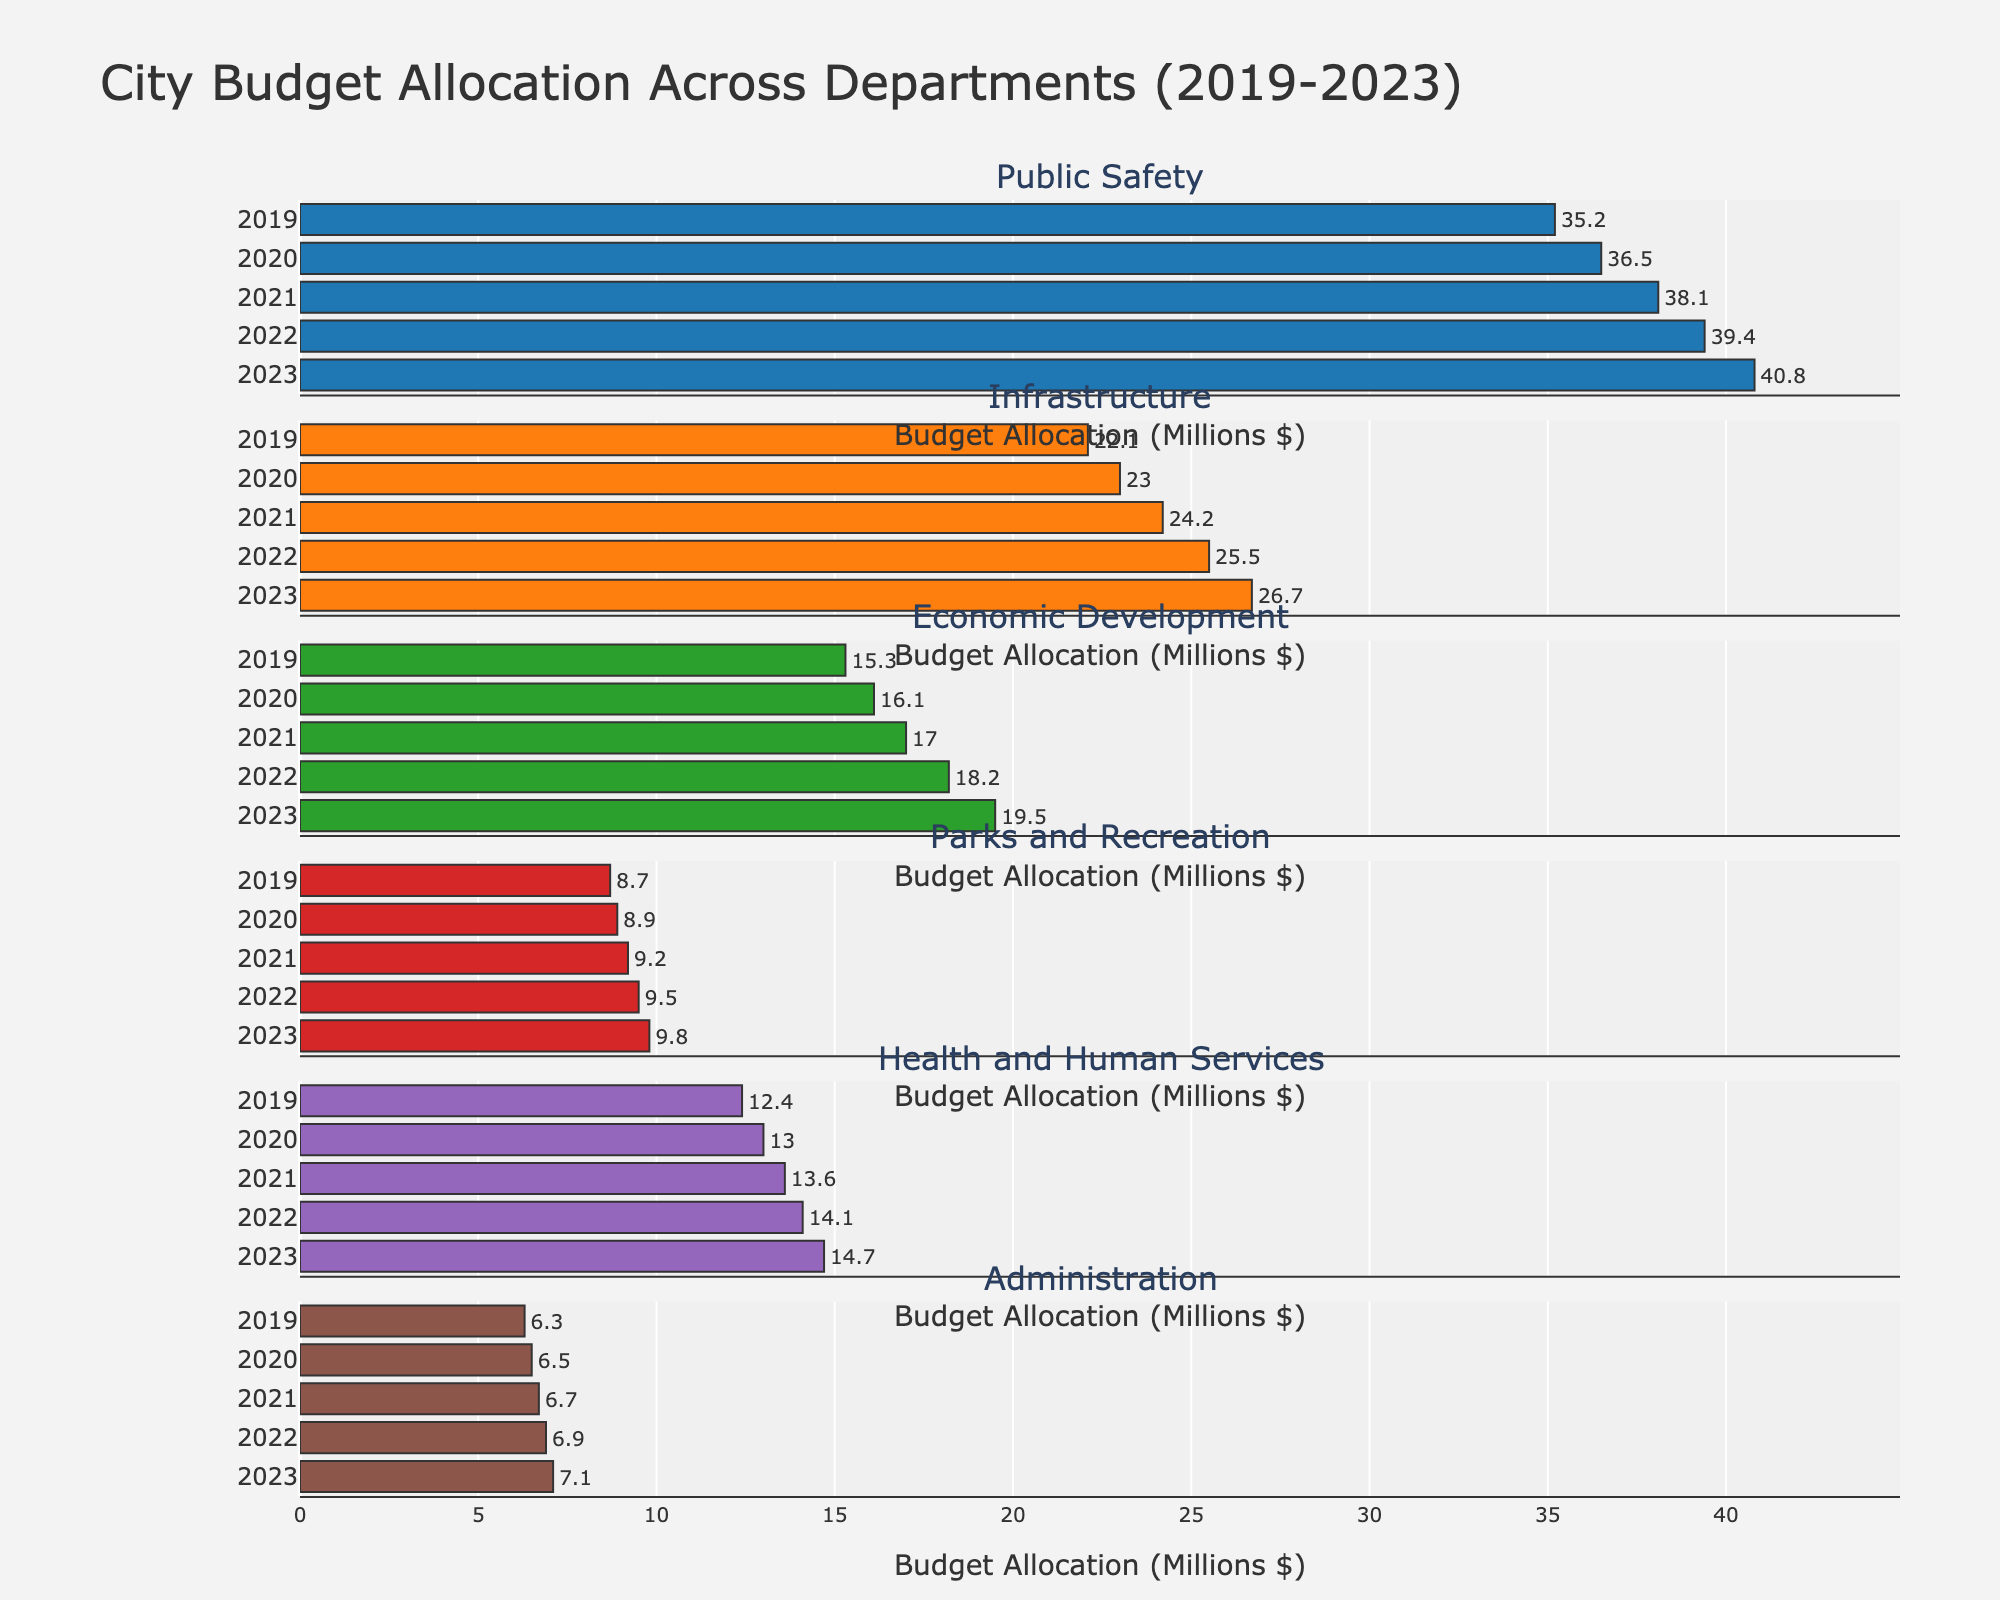What is the title of the figure? The title of the figure is prominently displayed at the top. It reads "City Budget Allocation Across Departments (2019-2023)."
Answer: City Budget Allocation Across Departments (2019-2023) Which department had the highest budget allocation in 2023? By observing the x-axis values for 2023 in the subplot, we can see that the department with the longest bar is "Public Safety", indicating the highest budget allocation for that year.
Answer: Public Safety How did the budget allocation for Administration change from 2019 to 2023? To answer this, we compare the x-axis lengths of the bars for the 'Administration' subplot in 2019 and 2023. In 2019, the value is 6.3, and in 2023, it is 7.1 million dollars. Subtracting the former from the latter shows an increase of 0.8 million dollars.
Answer: Increased by 0.8 million dollars What's the average budget allocation for Parks and Recreation over the 5 years? The average budget allocation is calculated by summing the yearly allocations (8.7 + 8.9 + 9.2 + 9.5 + 9.8) and then dividing by the number of years, which is 5. (8.7 + 8.9 + 9.2 + 9.5 + 9.8) / 5 = 46.1 / 5 = 9.22 million dollars on average.
Answer: 9.22 million dollars Which department saw the largest increase in budget allocation from 2019 to 2023? To find this, look at the increase in budget allocation for each department between 2019 and 2023. Public Safety increases from 35.2 to 40.8, Infrastructure from 22.1 to 26.7, Economic Development from 15.3 to 19.5, Parks and Recreation from 8.7 to 9.8, Health and Human Services from 12.4 to 14.7, Administration from 6.3 to 7.1. The largest increase is for Public Safety with 5.6 million dollars.
Answer: Public Safety What is the difference between the 2023 budget allocations for Public Safety and Economic Development? In 2023, the budget for Public Safety is 40.8 million dollars and for Economic Development, it is 19.5 million dollars. The difference is calculated as 40.8 - 19.5 = 21.3 million dollars.
Answer: 21.3 million dollars Which department had the smallest budget allocation in 2020? By observing the x-axis values for the year 2020 in each subplot, we see that the department with the shortest bar in 2020 is "Administration," which has a budget of 6.5 million dollars.
Answer: Administration What is the total budget allocation for Health and Human Services over the entire 5-year period? To find the total, sum the yearly values for Health and Human Services: 12.4 + 13.0 + 13.6 + 14.1 + 14.7 = 67.8 million dollars.
Answer: 67.8 million dollars Which department's budget allocations show a consistent year-over-year increase? Examining the trend in each subplot for a consistent upward direction, we find that the budgets for all departments (Public Safety, Infrastructure, Economic Development, Parks and Recreation, Health and Human Services, and Administration) consistently increased year-over-year.
Answer: All departments 